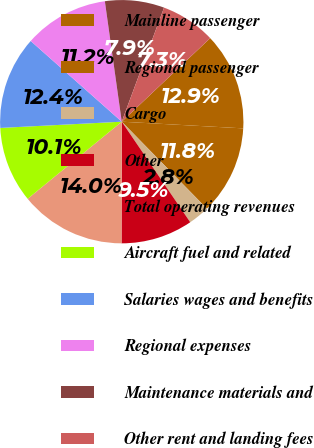Convert chart to OTSL. <chart><loc_0><loc_0><loc_500><loc_500><pie_chart><fcel>Mainline passenger<fcel>Regional passenger<fcel>Cargo<fcel>Other<fcel>Total operating revenues<fcel>Aircraft fuel and related<fcel>Salaries wages and benefits<fcel>Regional expenses<fcel>Maintenance materials and<fcel>Other rent and landing fees<nl><fcel>12.92%<fcel>11.8%<fcel>2.81%<fcel>9.55%<fcel>14.04%<fcel>10.11%<fcel>12.36%<fcel>11.24%<fcel>7.87%<fcel>7.3%<nl></chart> 